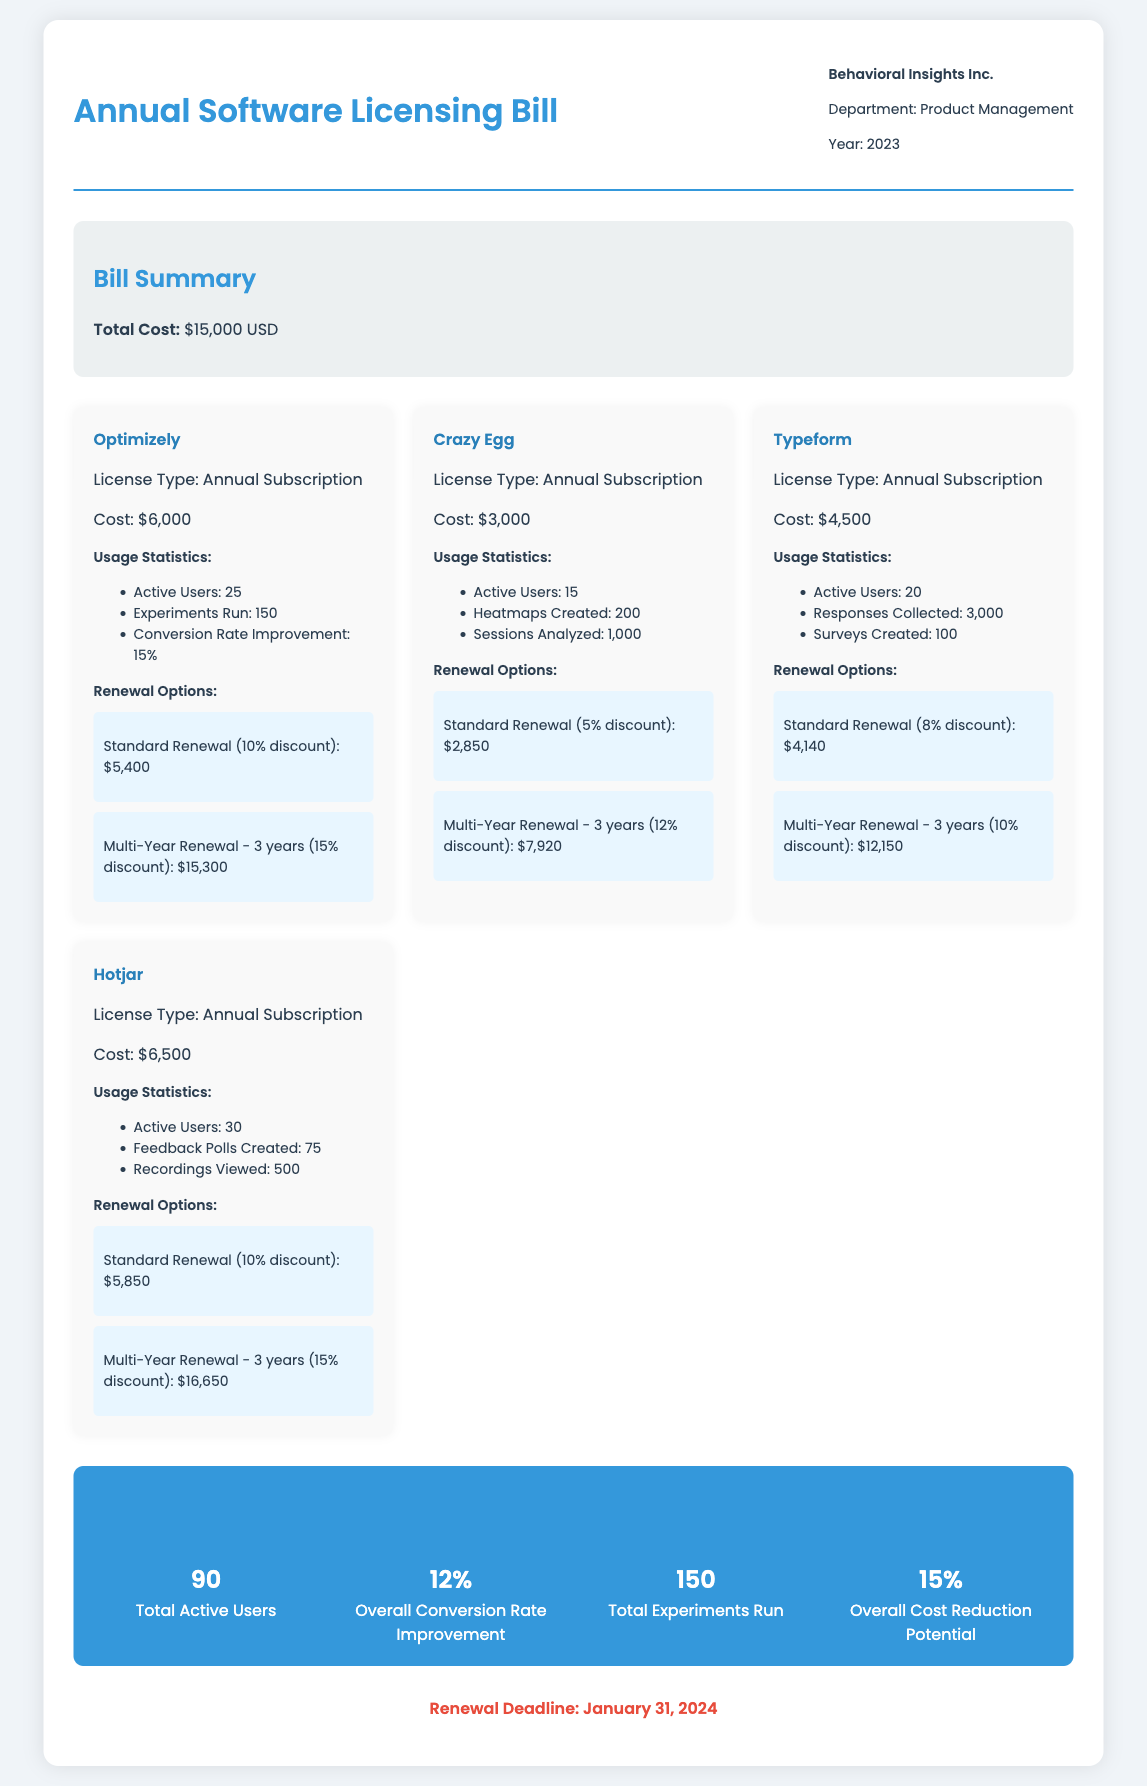What is the total cost of the bill? The total cost is explicitly stated in the bill summary section.
Answer: $15,000 USD How many active users does Hotjar have? The active users for each tool, including Hotjar, are detailed in the usage statistics section.
Answer: 30 What is the renewal deadline? The renewal deadline for the software licenses is mentioned at the end of the document.
Answer: January 31, 2024 What type of license does Crazy Egg offer? The license type for each tool is included in their respective details.
Answer: Annual Subscription What is the cost of the Standard Renewal for Optimizely? The Standard Renewal cost is provided in the renewal options of the tool section.
Answer: $5,400 How many sessions were analyzed by Crazy Egg? Usage statistics include numbers for sessions analyzed in Crazy Egg's details.
Answer: 1,000 What percentage is the overall cost reduction potential? The overall cost reduction potential is stated in the summary section of the document.
Answer: 15% What is the cost of Typeform's annual subscription? The cost of Typeform's annual subscription is listed in the tool's details.
Answer: $4,500 What is the overall conversion rate improvement? The overall conversion rate improvement is summarized at the end of the document.
Answer: 12% 